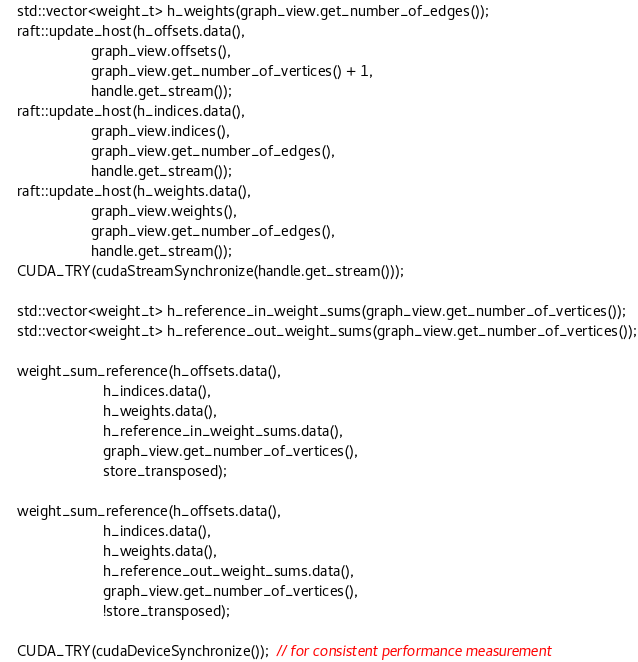<code> <loc_0><loc_0><loc_500><loc_500><_C++_>    std::vector<weight_t> h_weights(graph_view.get_number_of_edges());
    raft::update_host(h_offsets.data(),
                      graph_view.offsets(),
                      graph_view.get_number_of_vertices() + 1,
                      handle.get_stream());
    raft::update_host(h_indices.data(),
                      graph_view.indices(),
                      graph_view.get_number_of_edges(),
                      handle.get_stream());
    raft::update_host(h_weights.data(),
                      graph_view.weights(),
                      graph_view.get_number_of_edges(),
                      handle.get_stream());
    CUDA_TRY(cudaStreamSynchronize(handle.get_stream()));

    std::vector<weight_t> h_reference_in_weight_sums(graph_view.get_number_of_vertices());
    std::vector<weight_t> h_reference_out_weight_sums(graph_view.get_number_of_vertices());

    weight_sum_reference(h_offsets.data(),
                         h_indices.data(),
                         h_weights.data(),
                         h_reference_in_weight_sums.data(),
                         graph_view.get_number_of_vertices(),
                         store_transposed);

    weight_sum_reference(h_offsets.data(),
                         h_indices.data(),
                         h_weights.data(),
                         h_reference_out_weight_sums.data(),
                         graph_view.get_number_of_vertices(),
                         !store_transposed);

    CUDA_TRY(cudaDeviceSynchronize());  // for consistent performance measurement
</code> 